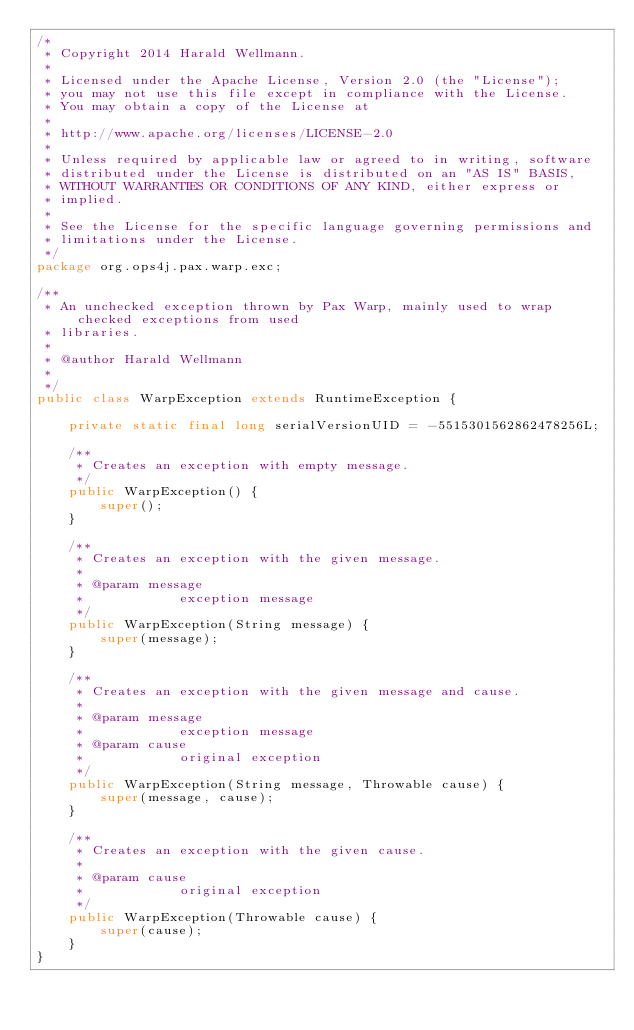<code> <loc_0><loc_0><loc_500><loc_500><_Java_>/*
 * Copyright 2014 Harald Wellmann.
 *
 * Licensed under the Apache License, Version 2.0 (the "License");
 * you may not use this file except in compliance with the License.
 * You may obtain a copy of the License at
 *
 * http://www.apache.org/licenses/LICENSE-2.0
 *
 * Unless required by applicable law or agreed to in writing, software
 * distributed under the License is distributed on an "AS IS" BASIS,
 * WITHOUT WARRANTIES OR CONDITIONS OF ANY KIND, either express or
 * implied.
 *
 * See the License for the specific language governing permissions and
 * limitations under the License.
 */
package org.ops4j.pax.warp.exc;

/**
 * An unchecked exception thrown by Pax Warp, mainly used to wrap checked exceptions from used
 * libraries.
 *
 * @author Harald Wellmann
 *
 */
public class WarpException extends RuntimeException {

    private static final long serialVersionUID = -5515301562862478256L;

    /**
     * Creates an exception with empty message.
     */
    public WarpException() {
        super();
    }

    /**
     * Creates an exception with the given message.
     *
     * @param message
     *            exception message
     */
    public WarpException(String message) {
        super(message);
    }

    /**
     * Creates an exception with the given message and cause.
     *
     * @param message
     *            exception message
     * @param cause
     *            original exception
     */
    public WarpException(String message, Throwable cause) {
        super(message, cause);
    }

    /**
     * Creates an exception with the given cause.
     *
     * @param cause
     *            original exception
     */
    public WarpException(Throwable cause) {
        super(cause);
    }
}
</code> 